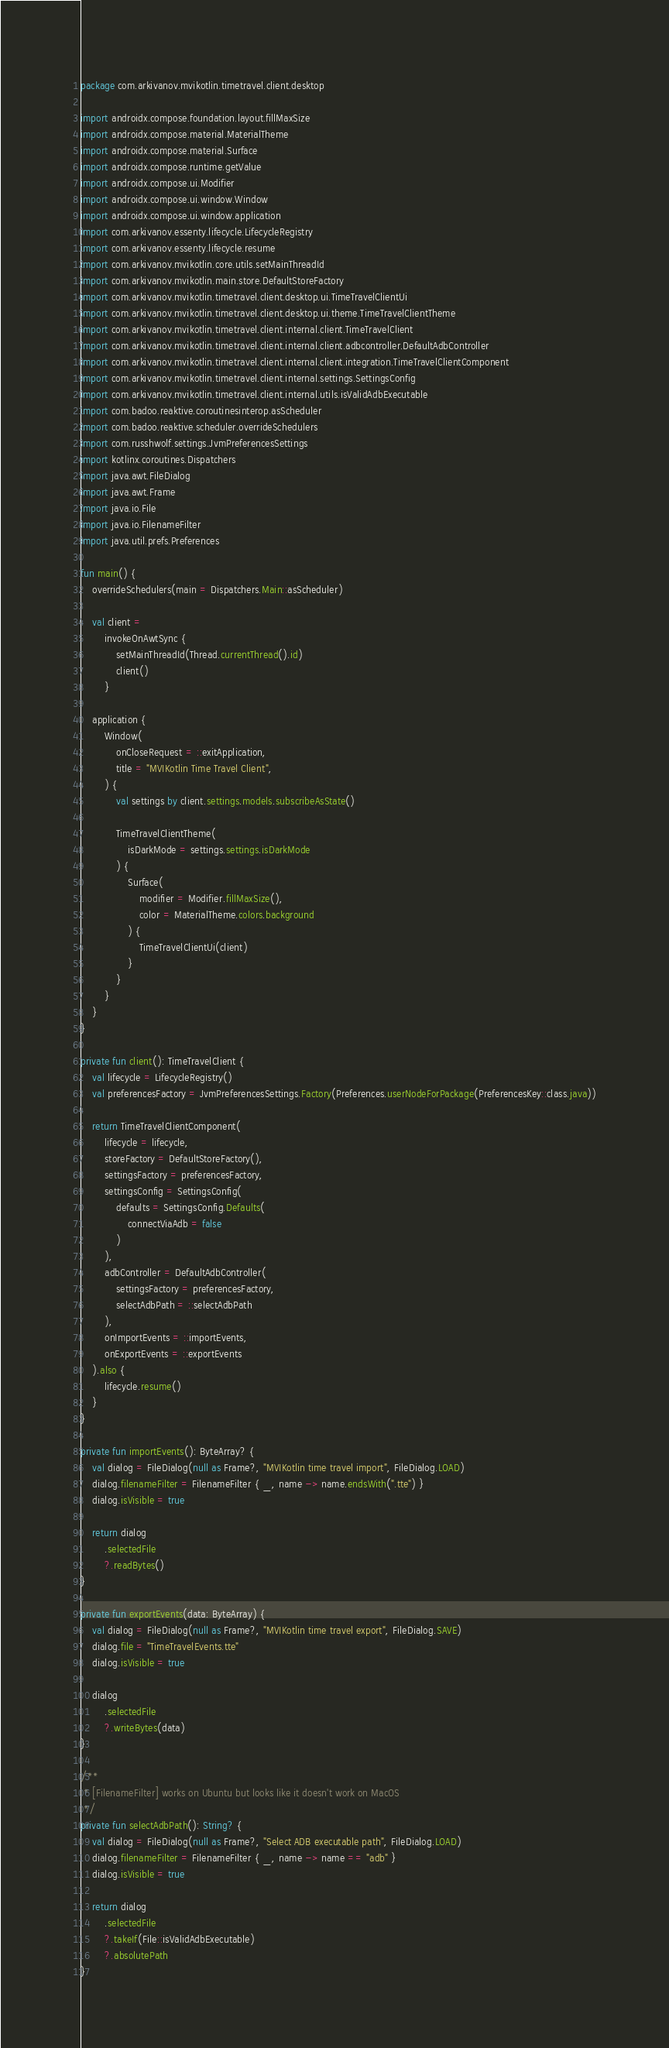Convert code to text. <code><loc_0><loc_0><loc_500><loc_500><_Kotlin_>package com.arkivanov.mvikotlin.timetravel.client.desktop

import androidx.compose.foundation.layout.fillMaxSize
import androidx.compose.material.MaterialTheme
import androidx.compose.material.Surface
import androidx.compose.runtime.getValue
import androidx.compose.ui.Modifier
import androidx.compose.ui.window.Window
import androidx.compose.ui.window.application
import com.arkivanov.essenty.lifecycle.LifecycleRegistry
import com.arkivanov.essenty.lifecycle.resume
import com.arkivanov.mvikotlin.core.utils.setMainThreadId
import com.arkivanov.mvikotlin.main.store.DefaultStoreFactory
import com.arkivanov.mvikotlin.timetravel.client.desktop.ui.TimeTravelClientUi
import com.arkivanov.mvikotlin.timetravel.client.desktop.ui.theme.TimeTravelClientTheme
import com.arkivanov.mvikotlin.timetravel.client.internal.client.TimeTravelClient
import com.arkivanov.mvikotlin.timetravel.client.internal.client.adbcontroller.DefaultAdbController
import com.arkivanov.mvikotlin.timetravel.client.internal.client.integration.TimeTravelClientComponent
import com.arkivanov.mvikotlin.timetravel.client.internal.settings.SettingsConfig
import com.arkivanov.mvikotlin.timetravel.client.internal.utils.isValidAdbExecutable
import com.badoo.reaktive.coroutinesinterop.asScheduler
import com.badoo.reaktive.scheduler.overrideSchedulers
import com.russhwolf.settings.JvmPreferencesSettings
import kotlinx.coroutines.Dispatchers
import java.awt.FileDialog
import java.awt.Frame
import java.io.File
import java.io.FilenameFilter
import java.util.prefs.Preferences

fun main() {
    overrideSchedulers(main = Dispatchers.Main::asScheduler)

    val client =
        invokeOnAwtSync {
            setMainThreadId(Thread.currentThread().id)
            client()
        }

    application {
        Window(
            onCloseRequest = ::exitApplication,
            title = "MVIKotlin Time Travel Client",
        ) {
            val settings by client.settings.models.subscribeAsState()

            TimeTravelClientTheme(
                isDarkMode = settings.settings.isDarkMode
            ) {
                Surface(
                    modifier = Modifier.fillMaxSize(),
                    color = MaterialTheme.colors.background
                ) {
                    TimeTravelClientUi(client)
                }
            }
        }
    }
}

private fun client(): TimeTravelClient {
    val lifecycle = LifecycleRegistry()
    val preferencesFactory = JvmPreferencesSettings.Factory(Preferences.userNodeForPackage(PreferencesKey::class.java))

    return TimeTravelClientComponent(
        lifecycle = lifecycle,
        storeFactory = DefaultStoreFactory(),
        settingsFactory = preferencesFactory,
        settingsConfig = SettingsConfig(
            defaults = SettingsConfig.Defaults(
                connectViaAdb = false
            )
        ),
        adbController = DefaultAdbController(
            settingsFactory = preferencesFactory,
            selectAdbPath = ::selectAdbPath
        ),
        onImportEvents = ::importEvents,
        onExportEvents = ::exportEvents
    ).also {
        lifecycle.resume()
    }
}

private fun importEvents(): ByteArray? {
    val dialog = FileDialog(null as Frame?, "MVIKotlin time travel import", FileDialog.LOAD)
    dialog.filenameFilter = FilenameFilter { _, name -> name.endsWith(".tte") }
    dialog.isVisible = true

    return dialog
        .selectedFile
        ?.readBytes()
}

private fun exportEvents(data: ByteArray) {
    val dialog = FileDialog(null as Frame?, "MVIKotlin time travel export", FileDialog.SAVE)
    dialog.file = "TimeTravelEvents.tte"
    dialog.isVisible = true

    dialog
        .selectedFile
        ?.writeBytes(data)
}

/**
 * [FilenameFilter] works on Ubuntu but looks like it doesn't work on MacOS
 */
private fun selectAdbPath(): String? {
    val dialog = FileDialog(null as Frame?, "Select ADB executable path", FileDialog.LOAD)
    dialog.filenameFilter = FilenameFilter { _, name -> name == "adb" }
    dialog.isVisible = true

    return dialog
        .selectedFile
        ?.takeIf(File::isValidAdbExecutable)
        ?.absolutePath
}
</code> 